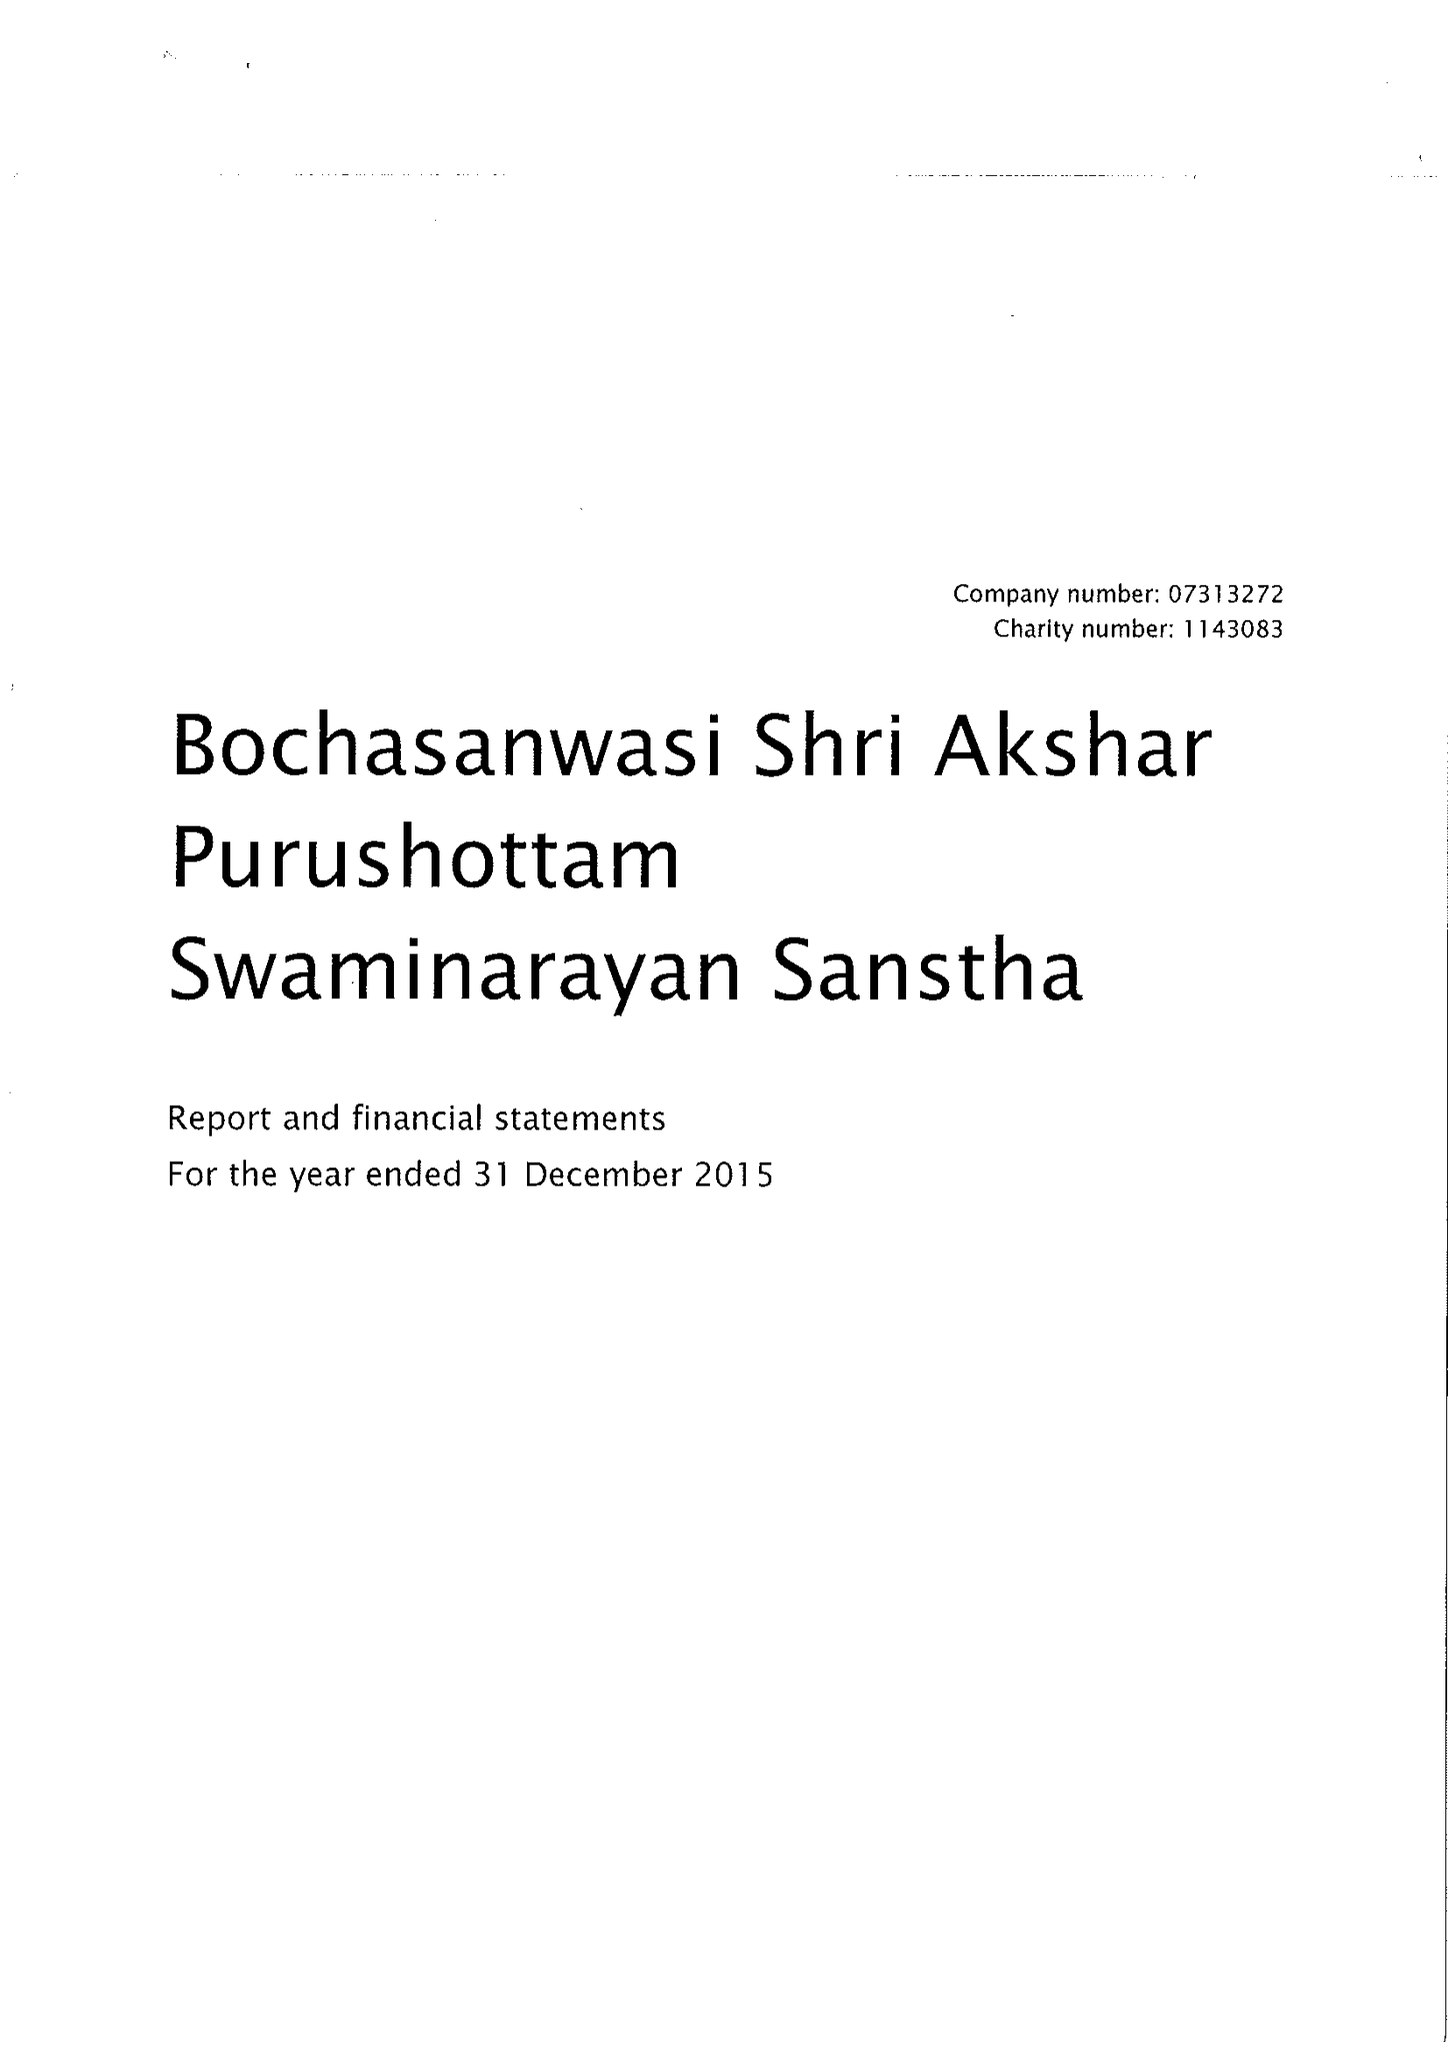What is the value for the charity_number?
Answer the question using a single word or phrase. 1143083 